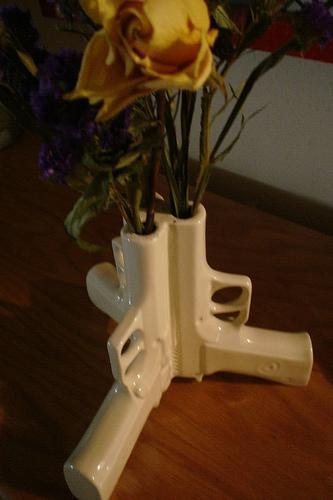How many men are wearing blue jeans?
Give a very brief answer. 0. 